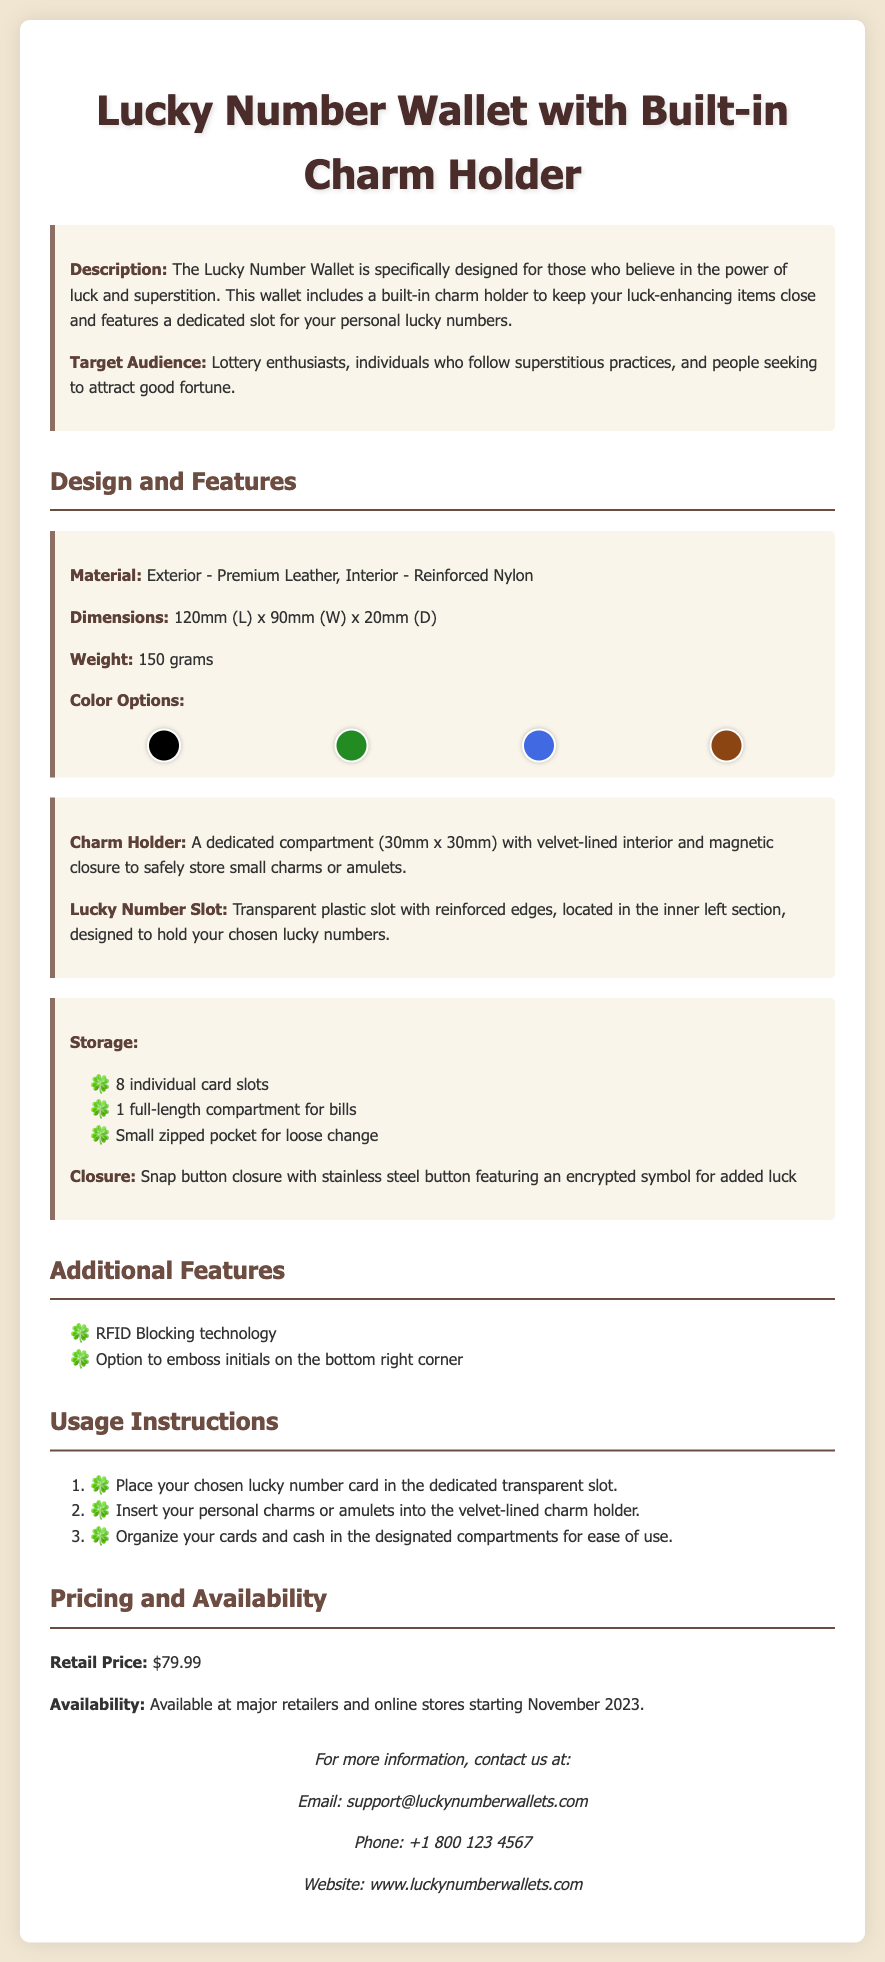What is the retail price of the wallet? The retail price is stated in the pricing section of the document.
Answer: $79.99 What materials are used for the wallet's exterior and interior? The materials are specified in the design features section of the document.
Answer: Premium Leather, Reinforced Nylon How many individual card slots does the wallet have? The number of card slots is listed under the storage features in the document.
Answer: 8 individual card slots What is the size of the charm holder compartment? The dimensions of the charm holder are provided in the features section of the document.
Answer: 30mm x 30mm Which technology is included for security? The document mentions technological features under additional features that ensure security.
Answer: RFID Blocking technology Who is the target audience for the wallet? The target audience is identified in the description section of the document.
Answer: Lottery enthusiasts What are the color options available for the wallet? The color options are shown in a dedicated section of the document.
Answer: Midnight Black, Forest Green, Royal Blue, Mystic Brown What kind of closure does the wallet have? The type of closure for the wallet is detailed under its features.
Answer: Snap button closure What are the usage instructions provided for the wallet? A step-by-step list is given under the usage instructions section of the document.
Answer: Place lucky number card, insert charms, organize cards and cash 